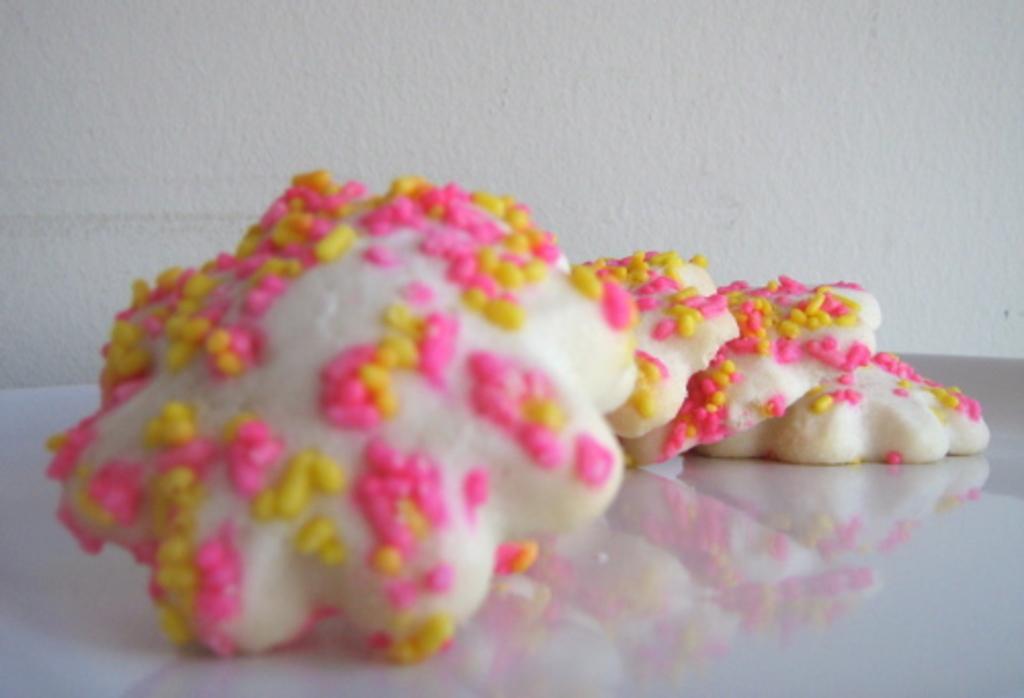Could you give a brief overview of what you see in this image? Here we can see food on a platform. There is a white background. 